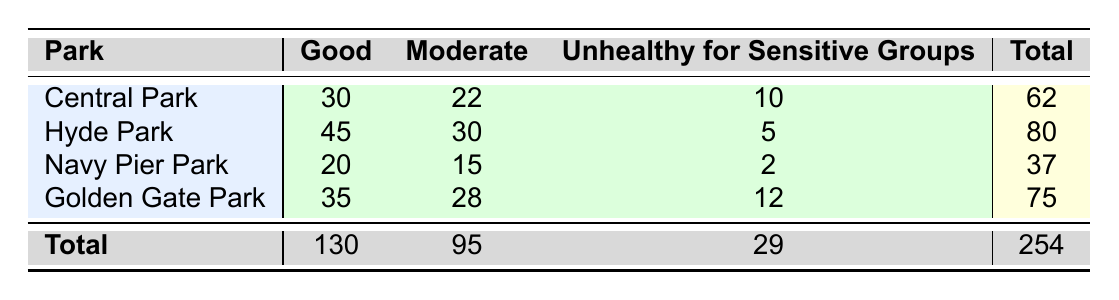What is the total number of mammal sightings in Central Park? The total number of mammal sightings in Central Park can be found by adding the values in the row for that park: 30 (Good) + 22 (Moderate) + 10 (Unhealthy for Sensitive Groups) = 62.
Answer: 62 Which park had the highest number of mammal sightings? By comparing the total sightings for each park, we can see that Hyde Park has the highest total of 80 sightings.
Answer: Hyde Park How many mammal sightings were recorded in parks categorized as "Unhealthy for Sensitive Groups"? To answer this, sum the mammal sightings for the "Unhealthy for Sensitive Groups" category across all parks: 10 (Central Park) + 5 (Hyde Park) + 2 (Navy Pier Park) + 12 (Golden Gate Park) = 29.
Answer: 29 Is the number of mammal sightings in the "Good" air quality category greater than those in the "Moderate" category? We can compare the totals for each category: Good has 130 sightings, and Moderate has 95 sightings. Since 130 > 95, the number in the Good category is greater.
Answer: Yes What is the average number of mammal sightings across all parks in "Moderate" air quality? The total sightings in the Moderate category is 95, and there are 4 parks. To find the average, divide 95 by 4: 95/4 = 23.75.
Answer: 23.75 In which park is the difference between "Good" and "Unhealthy for Sensitive Groups" sightings the greatest? The differences for each park are: Central Park (30 - 10 = 20), Hyde Park (45 - 5 = 40), Navy Pier Park (20 - 2 = 18), Golden Gate Park (35 - 12 = 23). The greatest difference is in Hyde Park, with 40.
Answer: Hyde Park How many more mammal sightings were there in the "Good" air quality category compared to "Unhealthy for Sensitive Groups" across all parks? First, the totals are found: Good has 130 sightings and Unhealthy for Sensitive Groups has 29. The difference is 130 - 29 = 101.
Answer: 101 What proportion of the total mammal sightings occur in parks that have a "Good" air quality index? The total mammal sightings are 254, and those in the Good category are 130. The proportion is then 130/254, which roughly equals 0.511 or 51.1%.
Answer: 51.1% 